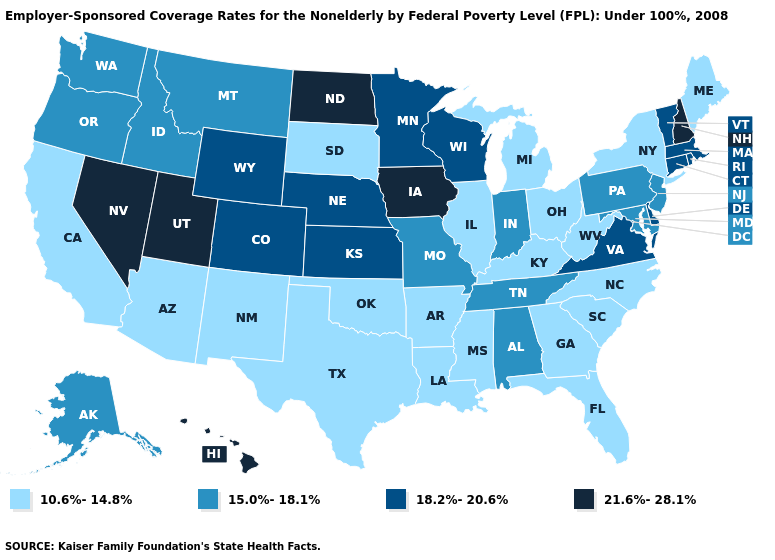Name the states that have a value in the range 18.2%-20.6%?
Keep it brief. Colorado, Connecticut, Delaware, Kansas, Massachusetts, Minnesota, Nebraska, Rhode Island, Vermont, Virginia, Wisconsin, Wyoming. Which states have the lowest value in the West?
Keep it brief. Arizona, California, New Mexico. Name the states that have a value in the range 15.0%-18.1%?
Concise answer only. Alabama, Alaska, Idaho, Indiana, Maryland, Missouri, Montana, New Jersey, Oregon, Pennsylvania, Tennessee, Washington. What is the value of Minnesota?
Give a very brief answer. 18.2%-20.6%. What is the highest value in the South ?
Keep it brief. 18.2%-20.6%. What is the lowest value in states that border Massachusetts?
Short answer required. 10.6%-14.8%. Does South Dakota have the highest value in the MidWest?
Concise answer only. No. What is the lowest value in states that border Illinois?
Short answer required. 10.6%-14.8%. What is the lowest value in the Northeast?
Concise answer only. 10.6%-14.8%. Which states have the highest value in the USA?
Short answer required. Hawaii, Iowa, Nevada, New Hampshire, North Dakota, Utah. Name the states that have a value in the range 10.6%-14.8%?
Keep it brief. Arizona, Arkansas, California, Florida, Georgia, Illinois, Kentucky, Louisiana, Maine, Michigan, Mississippi, New Mexico, New York, North Carolina, Ohio, Oklahoma, South Carolina, South Dakota, Texas, West Virginia. Does the map have missing data?
Concise answer only. No. What is the highest value in the USA?
Quick response, please. 21.6%-28.1%. Among the states that border North Dakota , does South Dakota have the lowest value?
Give a very brief answer. Yes. Name the states that have a value in the range 10.6%-14.8%?
Short answer required. Arizona, Arkansas, California, Florida, Georgia, Illinois, Kentucky, Louisiana, Maine, Michigan, Mississippi, New Mexico, New York, North Carolina, Ohio, Oklahoma, South Carolina, South Dakota, Texas, West Virginia. 